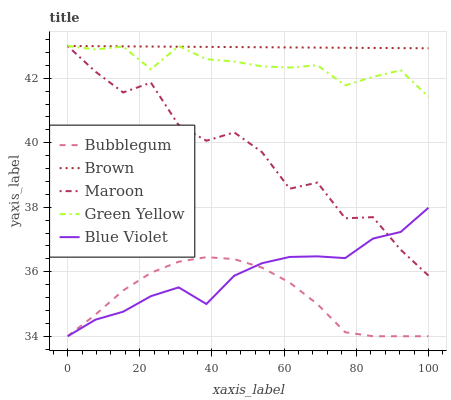Does Bubblegum have the minimum area under the curve?
Answer yes or no. Yes. Does Brown have the maximum area under the curve?
Answer yes or no. Yes. Does Green Yellow have the minimum area under the curve?
Answer yes or no. No. Does Green Yellow have the maximum area under the curve?
Answer yes or no. No. Is Brown the smoothest?
Answer yes or no. Yes. Is Maroon the roughest?
Answer yes or no. Yes. Is Green Yellow the smoothest?
Answer yes or no. No. Is Green Yellow the roughest?
Answer yes or no. No. Does Blue Violet have the lowest value?
Answer yes or no. Yes. Does Green Yellow have the lowest value?
Answer yes or no. No. Does Maroon have the highest value?
Answer yes or no. Yes. Does Bubblegum have the highest value?
Answer yes or no. No. Is Bubblegum less than Maroon?
Answer yes or no. Yes. Is Green Yellow greater than Bubblegum?
Answer yes or no. Yes. Does Blue Violet intersect Bubblegum?
Answer yes or no. Yes. Is Blue Violet less than Bubblegum?
Answer yes or no. No. Is Blue Violet greater than Bubblegum?
Answer yes or no. No. Does Bubblegum intersect Maroon?
Answer yes or no. No. 